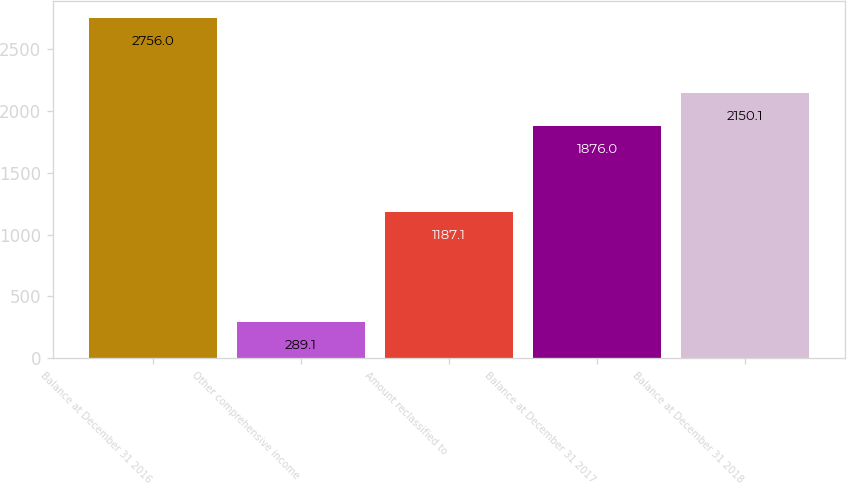<chart> <loc_0><loc_0><loc_500><loc_500><bar_chart><fcel>Balance at December 31 2016<fcel>Other comprehensive income<fcel>Amount reclassified to<fcel>Balance at December 31 2017<fcel>Balance at December 31 2018<nl><fcel>2756<fcel>289.1<fcel>1187.1<fcel>1876<fcel>2150.1<nl></chart> 